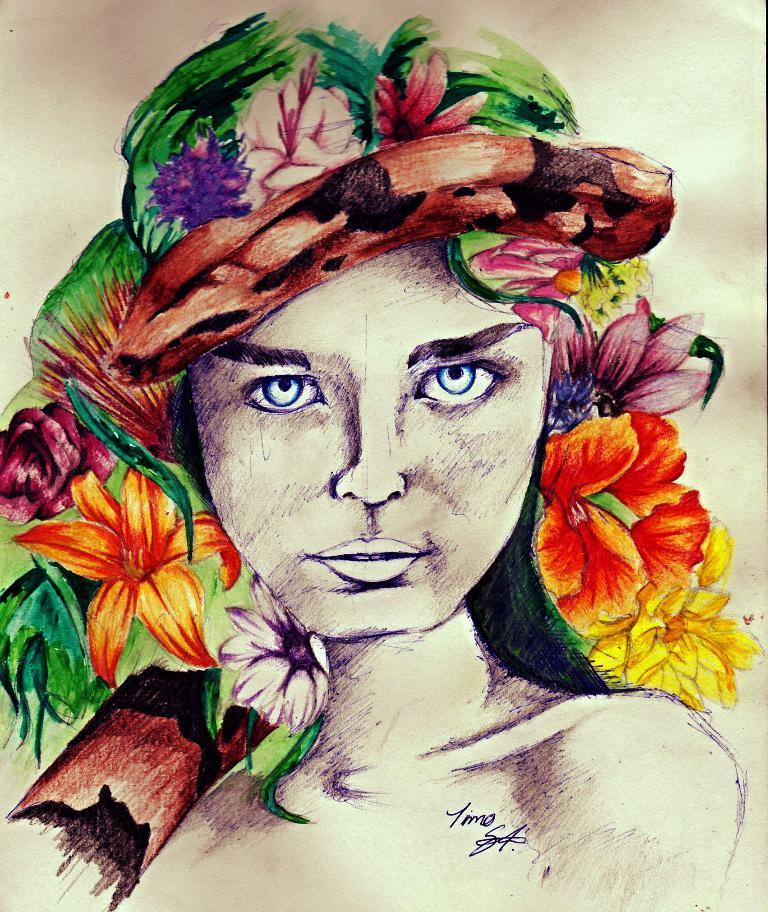Who is the main subject in the image? There is a woman in the image. What is the woman doing in the image? The woman is painting. What is the subject of the woman's painting? The painting contains colorful flowers. How are the flowers depicted in the painting? The flowers are depicted as being on the woman's head. What can be seen at the top of the image? There is text visible at the top of the image. What type of creature is sitting next to the woman while she paints? There is no creature present in the image; it only features the woman painting. How does the woman's haircut look in the image? The image does not show the woman's haircut, as it focuses on the flowers depicted on her head. 